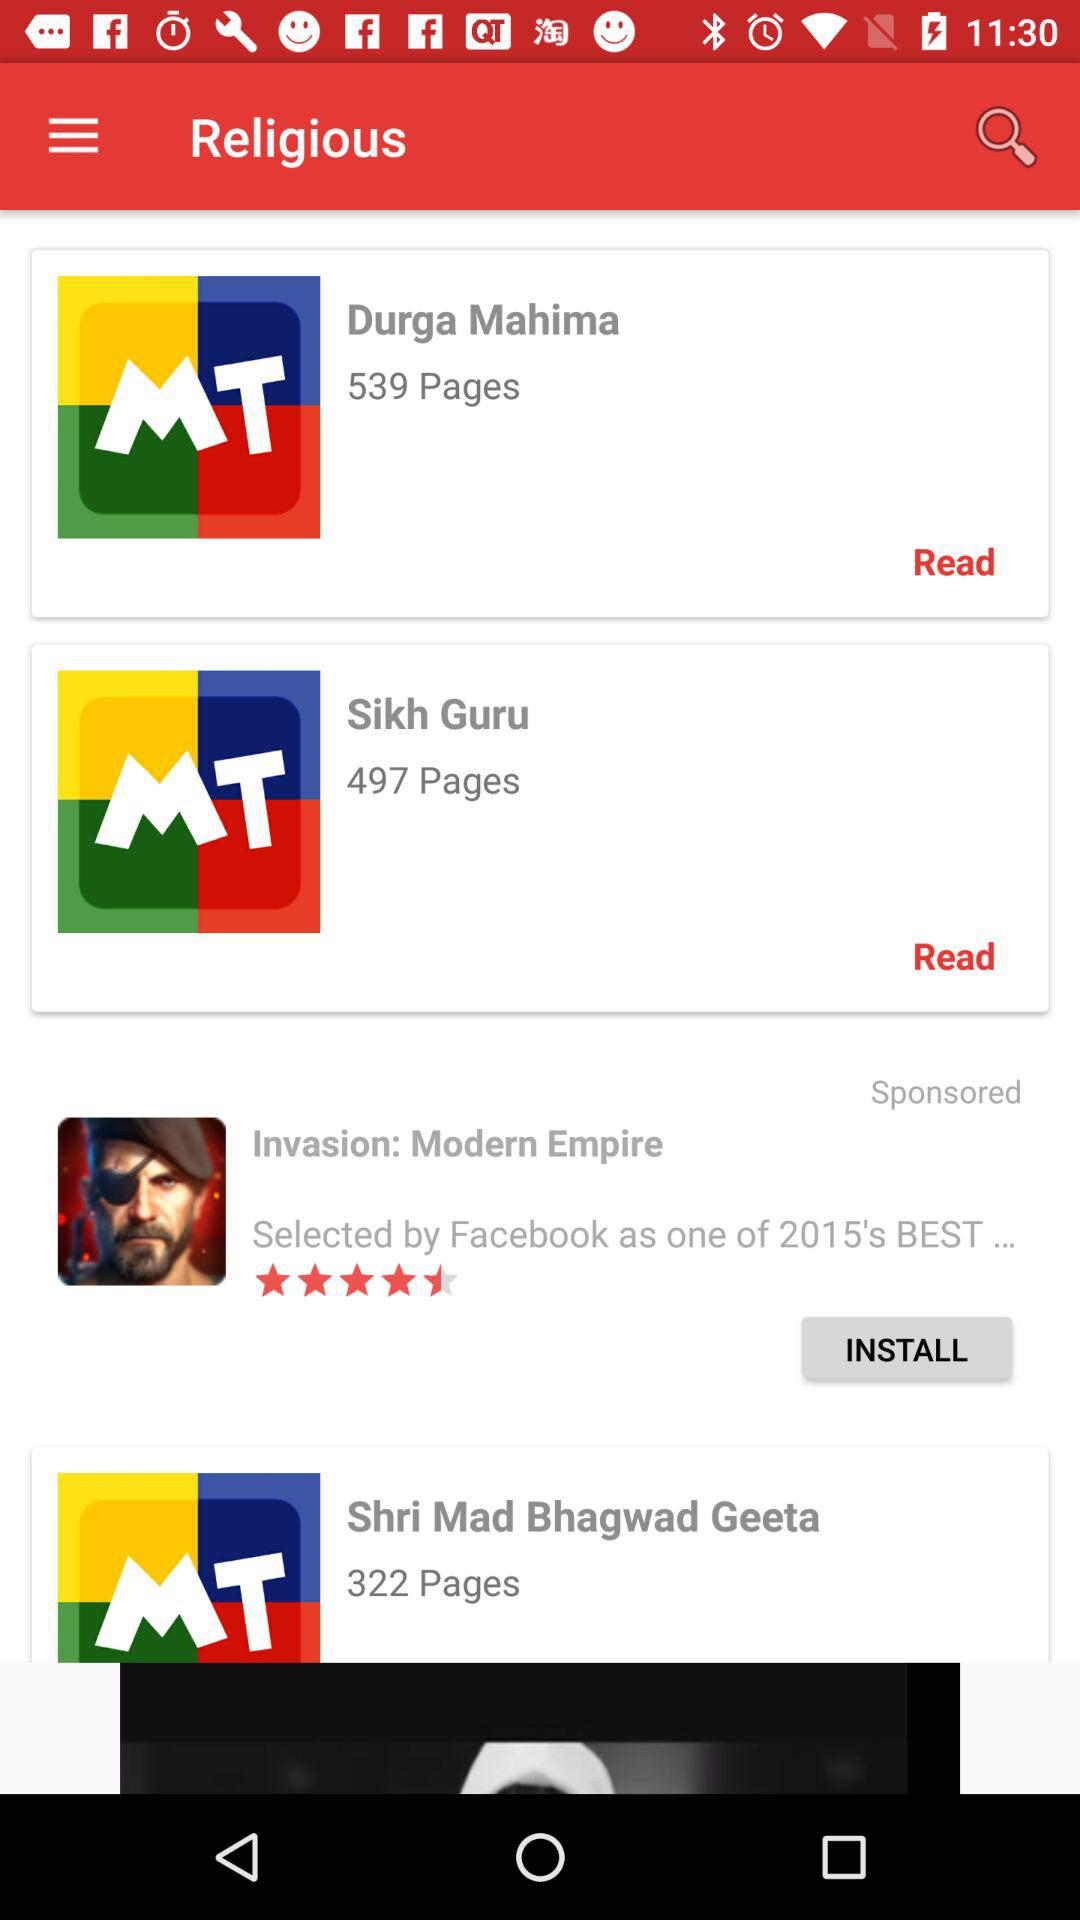How many pages are there in the "Sikh Guru"? There are 497 pages. 